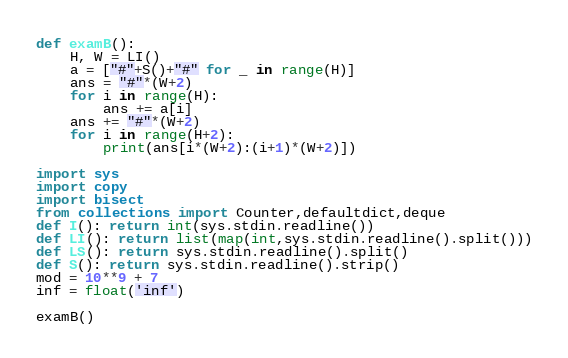Convert code to text. <code><loc_0><loc_0><loc_500><loc_500><_Python_>def examB():
    H, W = LI()
    a = ["#"+S()+"#" for _ in range(H)]
    ans = "#"*(W+2)
    for i in range(H):
        ans += a[i]
    ans += "#"*(W+2)
    for i in range(H+2):
        print(ans[i*(W+2):(i+1)*(W+2)])

import sys
import copy
import bisect
from collections import Counter,defaultdict,deque
def I(): return int(sys.stdin.readline())
def LI(): return list(map(int,sys.stdin.readline().split()))
def LS(): return sys.stdin.readline().split()
def S(): return sys.stdin.readline().strip()
mod = 10**9 + 7
inf = float('inf')

examB()
</code> 